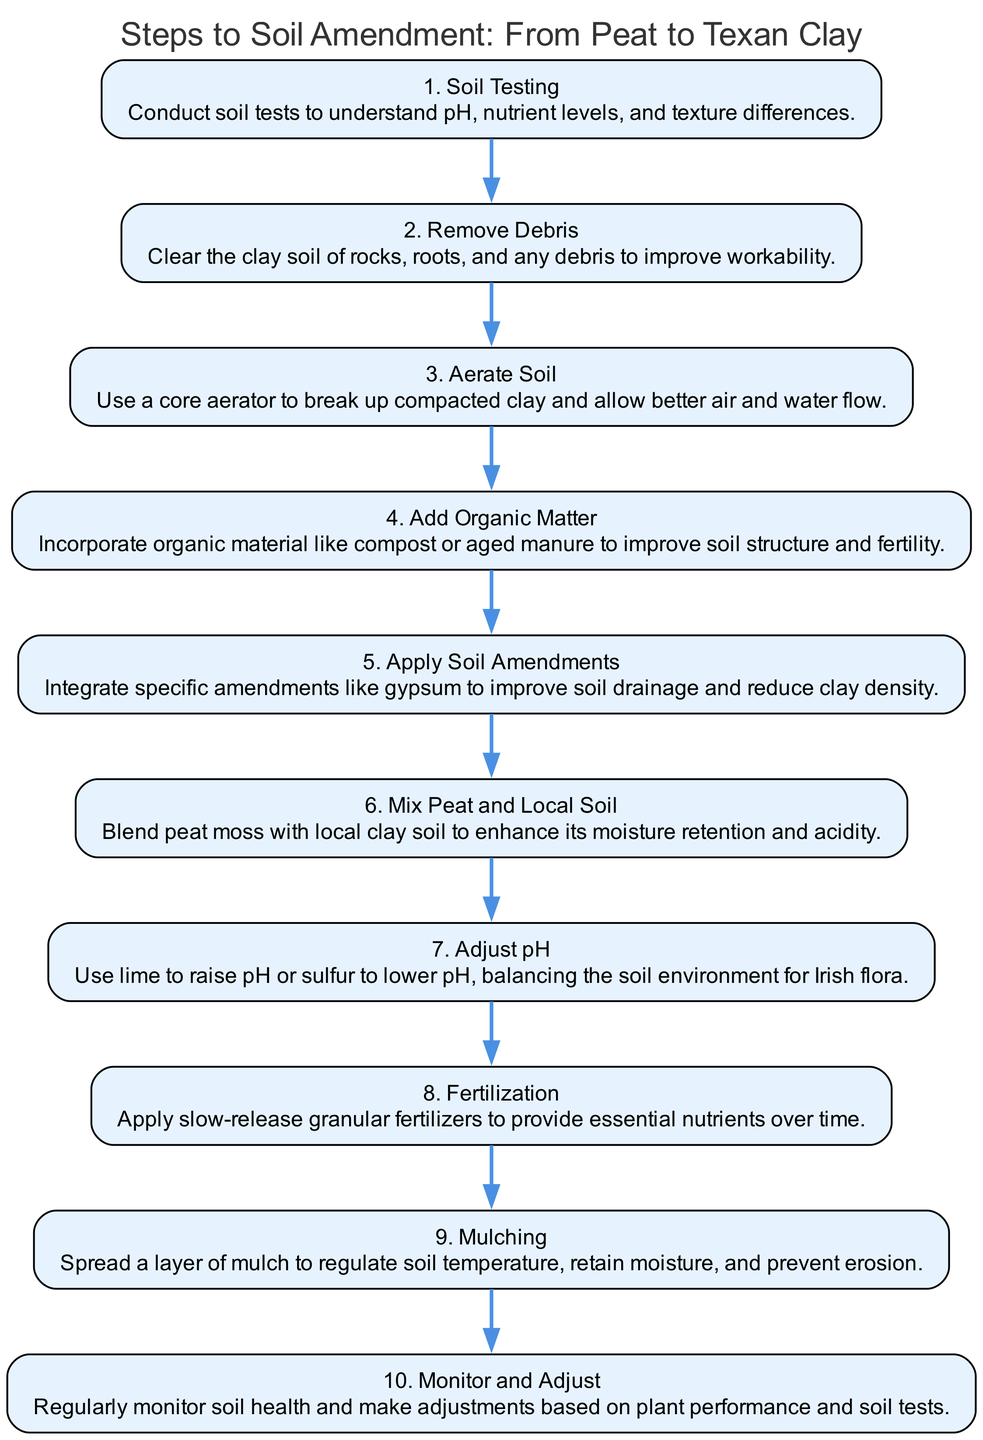What is the first step in the soil amendment process? The diagram lists the steps in a sequential manner, with the first step labeled as "1. Soil Testing." This indicates that soil testing is the initial action to take in the soil amendment process.
Answer: Soil Testing How many total steps are outlined in the diagram? By counting the elements in the diagram, it’s noted there are ten distinct steps listed, from soil testing to monitoring and adjusting.
Answer: 10 What follows after aerating the soil? The sequence highlights that the step "3. Aerate Soil" is immediately followed by "4. Add Organic Matter," indicating a direct relationship between aeration and the addition of organic material.
Answer: Add Organic Matter What is the purpose of applying gypsum in the soil amendment process? The diagram states that "5. Apply Soil Amendments" involves incorporating specific amendments like gypsum, primarily to improve drainage and reduce the density of clay soil.
Answer: Improve drainage Which step involves monitoring soil health? Looking through the steps, "10. Monitor and Adjust" indicates this is the final step focused on checking soil health and making any necessary adjustments to maintain optimal conditions.
Answer: Monitor and Adjust Which step requires adjusting pH? Reviewing the sequence, "7. Adjust pH" specifically mentions the need for pH adjustments to create a favorable environment for the plants, showing its importance in the pathway.
Answer: Adjust pH What is the connection between adding organic matter and soil structure? The diagram specifies that "4. Add Organic Matter" is intended to improve both soil structure and fertility, indicating a fundamental link in enhancing the quality of the soil for growth.
Answer: Improve soil structure What is the last step in the soil amendment process? The last step shown in the diagram is "10. Monitor and Adjust," indicating that ongoing assessment is vital to maintaining healthy soil conditions after amendments are made.
Answer: Monitor and Adjust 